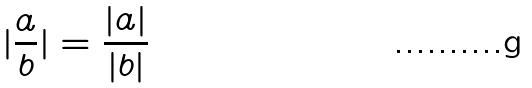<formula> <loc_0><loc_0><loc_500><loc_500>| \frac { a } { b } | = \frac { | a | } { | b | }</formula> 